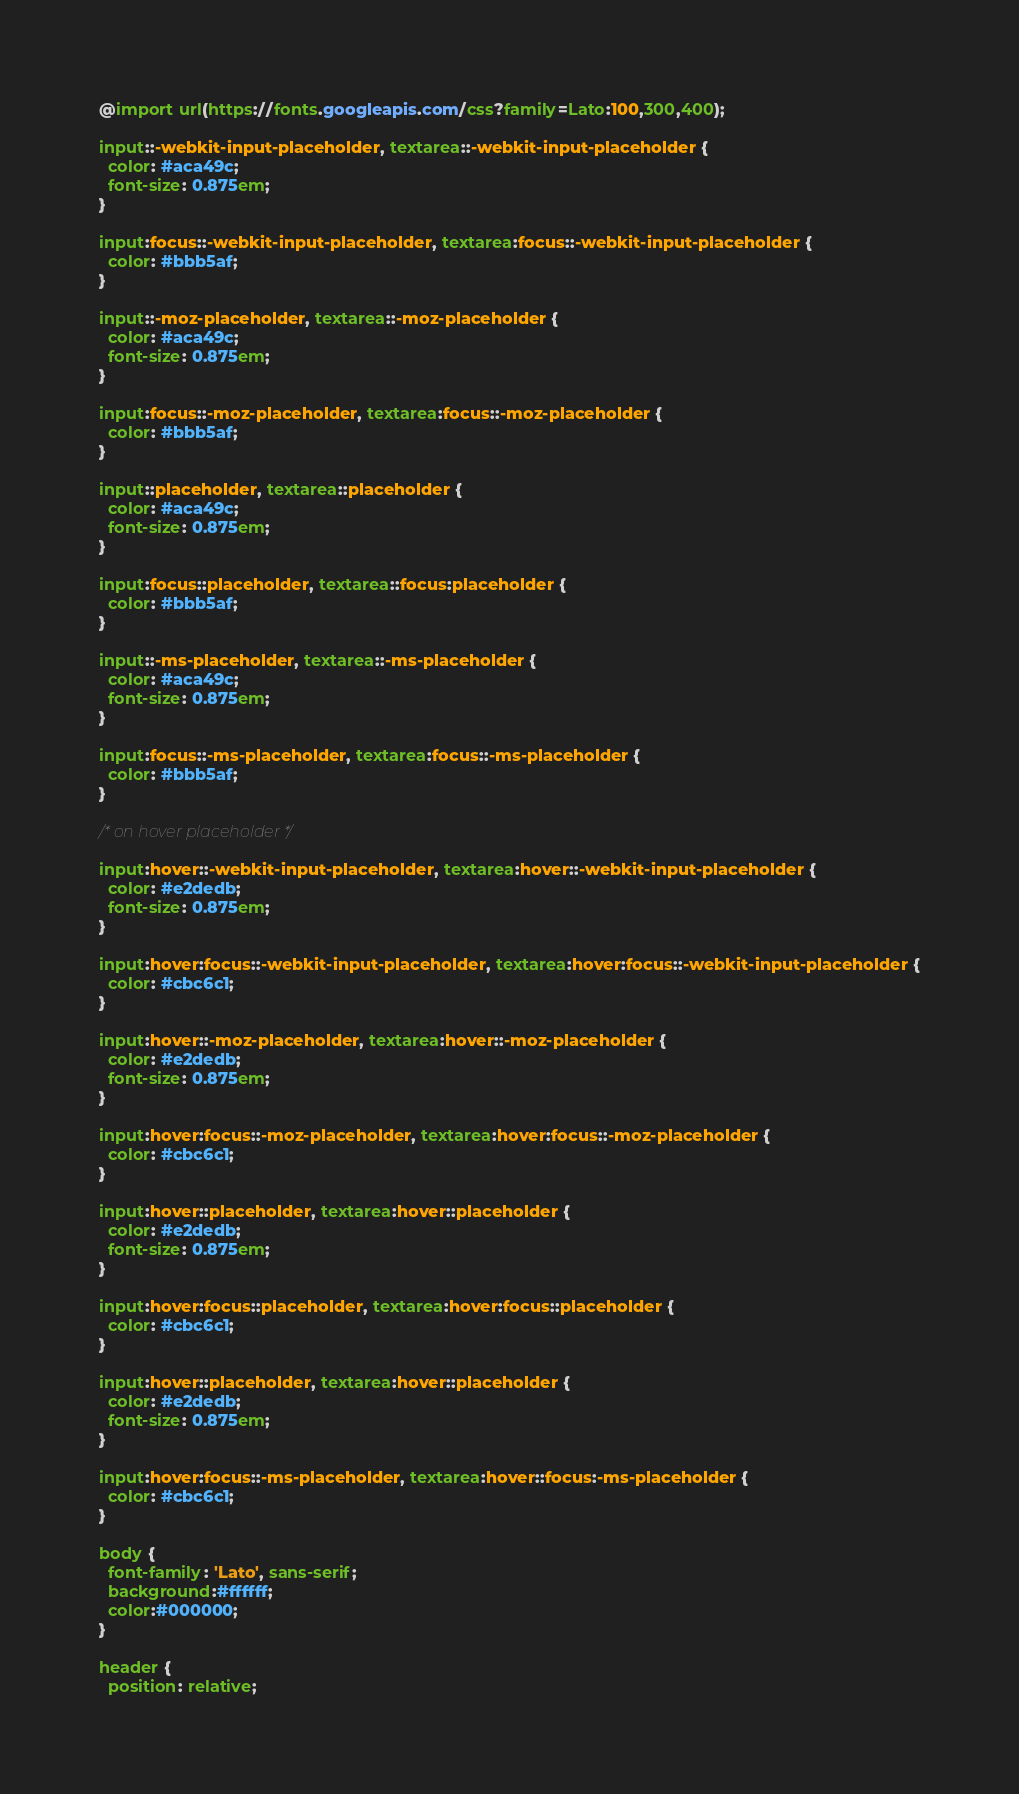Convert code to text. <code><loc_0><loc_0><loc_500><loc_500><_CSS_>@import url(https://fonts.googleapis.com/css?family=Lato:100,300,400);

input::-webkit-input-placeholder, textarea::-webkit-input-placeholder {
  color: #aca49c;
  font-size: 0.875em;
}

input:focus::-webkit-input-placeholder, textarea:focus::-webkit-input-placeholder {
  color: #bbb5af;
}

input::-moz-placeholder, textarea::-moz-placeholder {
  color: #aca49c;
  font-size: 0.875em;
}

input:focus::-moz-placeholder, textarea:focus::-moz-placeholder {
  color: #bbb5af;
}

input::placeholder, textarea::placeholder {
  color: #aca49c;
  font-size: 0.875em;
}

input:focus::placeholder, textarea::focus:placeholder {
  color: #bbb5af;
}

input::-ms-placeholder, textarea::-ms-placeholder {
  color: #aca49c;
  font-size: 0.875em;
}

input:focus::-ms-placeholder, textarea:focus::-ms-placeholder {
  color: #bbb5af;
}

/* on hover placeholder */

input:hover::-webkit-input-placeholder, textarea:hover::-webkit-input-placeholder {
  color: #e2dedb;
  font-size: 0.875em;
}

input:hover:focus::-webkit-input-placeholder, textarea:hover:focus::-webkit-input-placeholder {
  color: #cbc6c1;
}

input:hover::-moz-placeholder, textarea:hover::-moz-placeholder {
  color: #e2dedb;
  font-size: 0.875em;
}

input:hover:focus::-moz-placeholder, textarea:hover:focus::-moz-placeholder {
  color: #cbc6c1;
}

input:hover::placeholder, textarea:hover::placeholder {
  color: #e2dedb;
  font-size: 0.875em;
}

input:hover:focus::placeholder, textarea:hover:focus::placeholder {
  color: #cbc6c1;
}

input:hover::placeholder, textarea:hover::placeholder {
  color: #e2dedb;
  font-size: 0.875em;
}

input:hover:focus::-ms-placeholder, textarea:hover::focus:-ms-placeholder {
  color: #cbc6c1;
}

body {
  font-family: 'Lato', sans-serif;
  background:#ffffff;
  color:#000000;
}

header {
  position: relative;</code> 